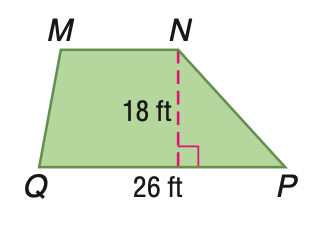Answer the mathemtical geometry problem and directly provide the correct option letter.
Question: Trapezoid M N P Q has an area of 360 square feet. Find the length of M N.
Choices: A: 14 B: 16 C: 18 D: 20 A 